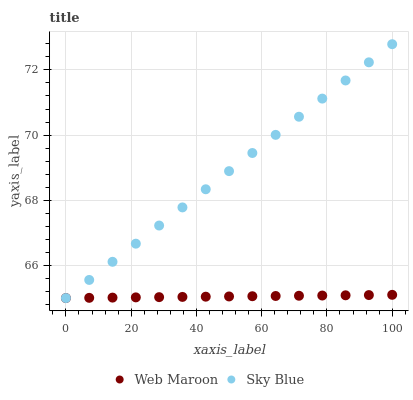Does Web Maroon have the minimum area under the curve?
Answer yes or no. Yes. Does Sky Blue have the maximum area under the curve?
Answer yes or no. Yes. Does Web Maroon have the maximum area under the curve?
Answer yes or no. No. Is Sky Blue the smoothest?
Answer yes or no. Yes. Is Web Maroon the roughest?
Answer yes or no. Yes. Is Web Maroon the smoothest?
Answer yes or no. No. Does Sky Blue have the lowest value?
Answer yes or no. Yes. Does Sky Blue have the highest value?
Answer yes or no. Yes. Does Web Maroon have the highest value?
Answer yes or no. No. Does Web Maroon intersect Sky Blue?
Answer yes or no. Yes. Is Web Maroon less than Sky Blue?
Answer yes or no. No. Is Web Maroon greater than Sky Blue?
Answer yes or no. No. 